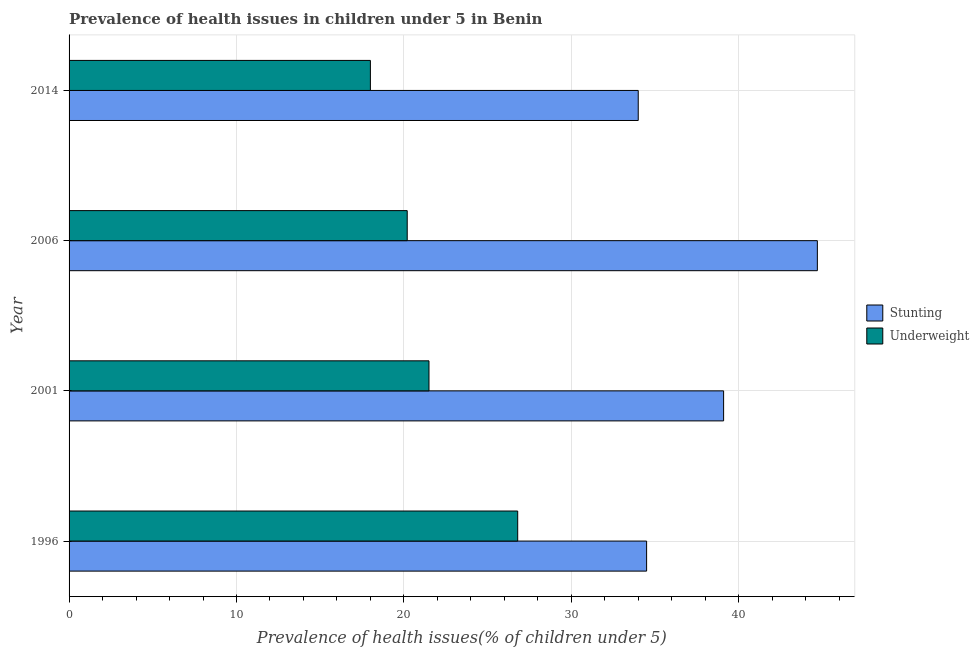How many different coloured bars are there?
Your response must be concise. 2. How many groups of bars are there?
Provide a short and direct response. 4. Are the number of bars per tick equal to the number of legend labels?
Provide a succinct answer. Yes. What is the percentage of stunted children in 2001?
Keep it short and to the point. 39.1. Across all years, what is the maximum percentage of underweight children?
Your answer should be compact. 26.8. In which year was the percentage of underweight children maximum?
Make the answer very short. 1996. In which year was the percentage of underweight children minimum?
Provide a short and direct response. 2014. What is the total percentage of stunted children in the graph?
Your answer should be compact. 152.3. What is the difference between the percentage of underweight children in 2006 and the percentage of stunted children in 2014?
Your response must be concise. -13.8. What is the average percentage of underweight children per year?
Ensure brevity in your answer.  21.62. In how many years, is the percentage of underweight children greater than 24 %?
Your answer should be compact. 1. What is the ratio of the percentage of underweight children in 1996 to that in 2001?
Provide a short and direct response. 1.25. What does the 1st bar from the top in 2014 represents?
Your response must be concise. Underweight. What does the 1st bar from the bottom in 2014 represents?
Provide a short and direct response. Stunting. How many bars are there?
Make the answer very short. 8. Are all the bars in the graph horizontal?
Keep it short and to the point. Yes. How many years are there in the graph?
Ensure brevity in your answer.  4. Are the values on the major ticks of X-axis written in scientific E-notation?
Offer a terse response. No. Does the graph contain any zero values?
Give a very brief answer. No. Does the graph contain grids?
Your response must be concise. Yes. How many legend labels are there?
Keep it short and to the point. 2. How are the legend labels stacked?
Make the answer very short. Vertical. What is the title of the graph?
Your answer should be compact. Prevalence of health issues in children under 5 in Benin. Does "Mobile cellular" appear as one of the legend labels in the graph?
Make the answer very short. No. What is the label or title of the X-axis?
Provide a succinct answer. Prevalence of health issues(% of children under 5). What is the Prevalence of health issues(% of children under 5) of Stunting in 1996?
Offer a very short reply. 34.5. What is the Prevalence of health issues(% of children under 5) in Underweight in 1996?
Ensure brevity in your answer.  26.8. What is the Prevalence of health issues(% of children under 5) in Stunting in 2001?
Your answer should be very brief. 39.1. What is the Prevalence of health issues(% of children under 5) in Underweight in 2001?
Provide a succinct answer. 21.5. What is the Prevalence of health issues(% of children under 5) in Stunting in 2006?
Offer a very short reply. 44.7. What is the Prevalence of health issues(% of children under 5) in Underweight in 2006?
Your response must be concise. 20.2. Across all years, what is the maximum Prevalence of health issues(% of children under 5) of Stunting?
Make the answer very short. 44.7. Across all years, what is the maximum Prevalence of health issues(% of children under 5) in Underweight?
Your answer should be very brief. 26.8. Across all years, what is the minimum Prevalence of health issues(% of children under 5) of Underweight?
Offer a very short reply. 18. What is the total Prevalence of health issues(% of children under 5) of Stunting in the graph?
Provide a succinct answer. 152.3. What is the total Prevalence of health issues(% of children under 5) of Underweight in the graph?
Your answer should be very brief. 86.5. What is the difference between the Prevalence of health issues(% of children under 5) in Stunting in 1996 and that in 2001?
Provide a short and direct response. -4.6. What is the difference between the Prevalence of health issues(% of children under 5) in Stunting in 1996 and that in 2006?
Offer a terse response. -10.2. What is the difference between the Prevalence of health issues(% of children under 5) of Underweight in 1996 and that in 2006?
Your response must be concise. 6.6. What is the difference between the Prevalence of health issues(% of children under 5) in Stunting in 1996 and that in 2014?
Make the answer very short. 0.5. What is the difference between the Prevalence of health issues(% of children under 5) of Underweight in 1996 and that in 2014?
Provide a short and direct response. 8.8. What is the difference between the Prevalence of health issues(% of children under 5) of Stunting in 2001 and that in 2006?
Make the answer very short. -5.6. What is the difference between the Prevalence of health issues(% of children under 5) in Underweight in 2001 and that in 2014?
Your response must be concise. 3.5. What is the difference between the Prevalence of health issues(% of children under 5) in Stunting in 1996 and the Prevalence of health issues(% of children under 5) in Underweight in 2001?
Give a very brief answer. 13. What is the difference between the Prevalence of health issues(% of children under 5) in Stunting in 1996 and the Prevalence of health issues(% of children under 5) in Underweight in 2006?
Your answer should be very brief. 14.3. What is the difference between the Prevalence of health issues(% of children under 5) of Stunting in 1996 and the Prevalence of health issues(% of children under 5) of Underweight in 2014?
Ensure brevity in your answer.  16.5. What is the difference between the Prevalence of health issues(% of children under 5) in Stunting in 2001 and the Prevalence of health issues(% of children under 5) in Underweight in 2006?
Your answer should be very brief. 18.9. What is the difference between the Prevalence of health issues(% of children under 5) in Stunting in 2001 and the Prevalence of health issues(% of children under 5) in Underweight in 2014?
Keep it short and to the point. 21.1. What is the difference between the Prevalence of health issues(% of children under 5) of Stunting in 2006 and the Prevalence of health issues(% of children under 5) of Underweight in 2014?
Make the answer very short. 26.7. What is the average Prevalence of health issues(% of children under 5) of Stunting per year?
Keep it short and to the point. 38.08. What is the average Prevalence of health issues(% of children under 5) of Underweight per year?
Give a very brief answer. 21.62. In the year 1996, what is the difference between the Prevalence of health issues(% of children under 5) of Stunting and Prevalence of health issues(% of children under 5) of Underweight?
Ensure brevity in your answer.  7.7. In the year 2014, what is the difference between the Prevalence of health issues(% of children under 5) of Stunting and Prevalence of health issues(% of children under 5) of Underweight?
Your answer should be very brief. 16. What is the ratio of the Prevalence of health issues(% of children under 5) of Stunting in 1996 to that in 2001?
Your answer should be compact. 0.88. What is the ratio of the Prevalence of health issues(% of children under 5) in Underweight in 1996 to that in 2001?
Offer a very short reply. 1.25. What is the ratio of the Prevalence of health issues(% of children under 5) of Stunting in 1996 to that in 2006?
Provide a succinct answer. 0.77. What is the ratio of the Prevalence of health issues(% of children under 5) of Underweight in 1996 to that in 2006?
Offer a very short reply. 1.33. What is the ratio of the Prevalence of health issues(% of children under 5) in Stunting in 1996 to that in 2014?
Your response must be concise. 1.01. What is the ratio of the Prevalence of health issues(% of children under 5) in Underweight in 1996 to that in 2014?
Your response must be concise. 1.49. What is the ratio of the Prevalence of health issues(% of children under 5) of Stunting in 2001 to that in 2006?
Provide a succinct answer. 0.87. What is the ratio of the Prevalence of health issues(% of children under 5) in Underweight in 2001 to that in 2006?
Offer a terse response. 1.06. What is the ratio of the Prevalence of health issues(% of children under 5) of Stunting in 2001 to that in 2014?
Ensure brevity in your answer.  1.15. What is the ratio of the Prevalence of health issues(% of children under 5) of Underweight in 2001 to that in 2014?
Your answer should be very brief. 1.19. What is the ratio of the Prevalence of health issues(% of children under 5) in Stunting in 2006 to that in 2014?
Make the answer very short. 1.31. What is the ratio of the Prevalence of health issues(% of children under 5) of Underweight in 2006 to that in 2014?
Keep it short and to the point. 1.12. What is the difference between the highest and the lowest Prevalence of health issues(% of children under 5) in Underweight?
Provide a short and direct response. 8.8. 